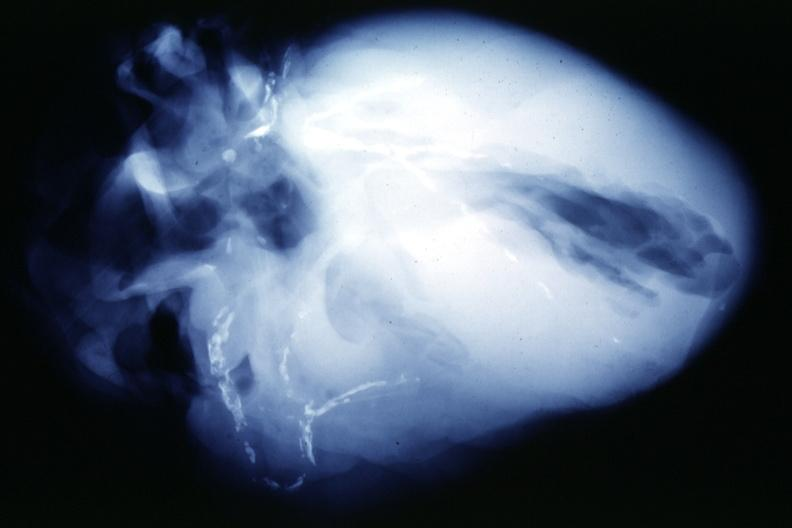s slide present?
Answer the question using a single word or phrase. No 